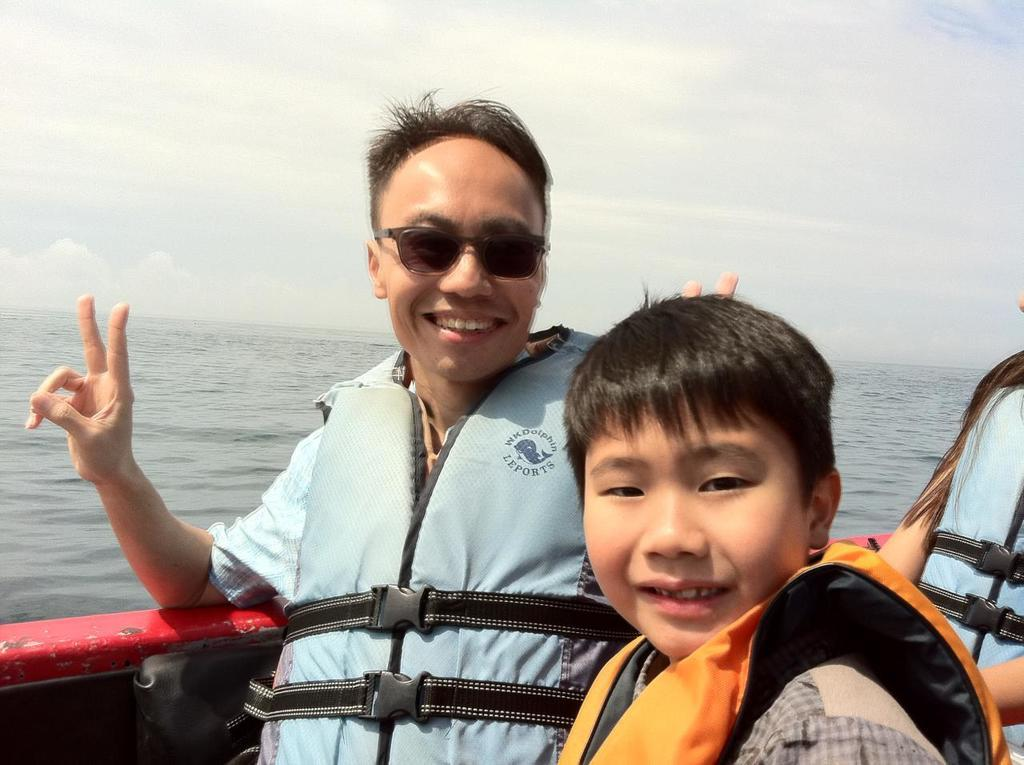Who or what is present in the image? There are people in the image. What are the people doing in the image? The people are sitting in a boat. What are the people wearing in the image? The people are wearing jackets. What can be seen in the background of the image? There is sky and water visible in the background of the image. What books are the people reading in the image? There are no books present in the image; the people are sitting in a boat and wearing jackets. 